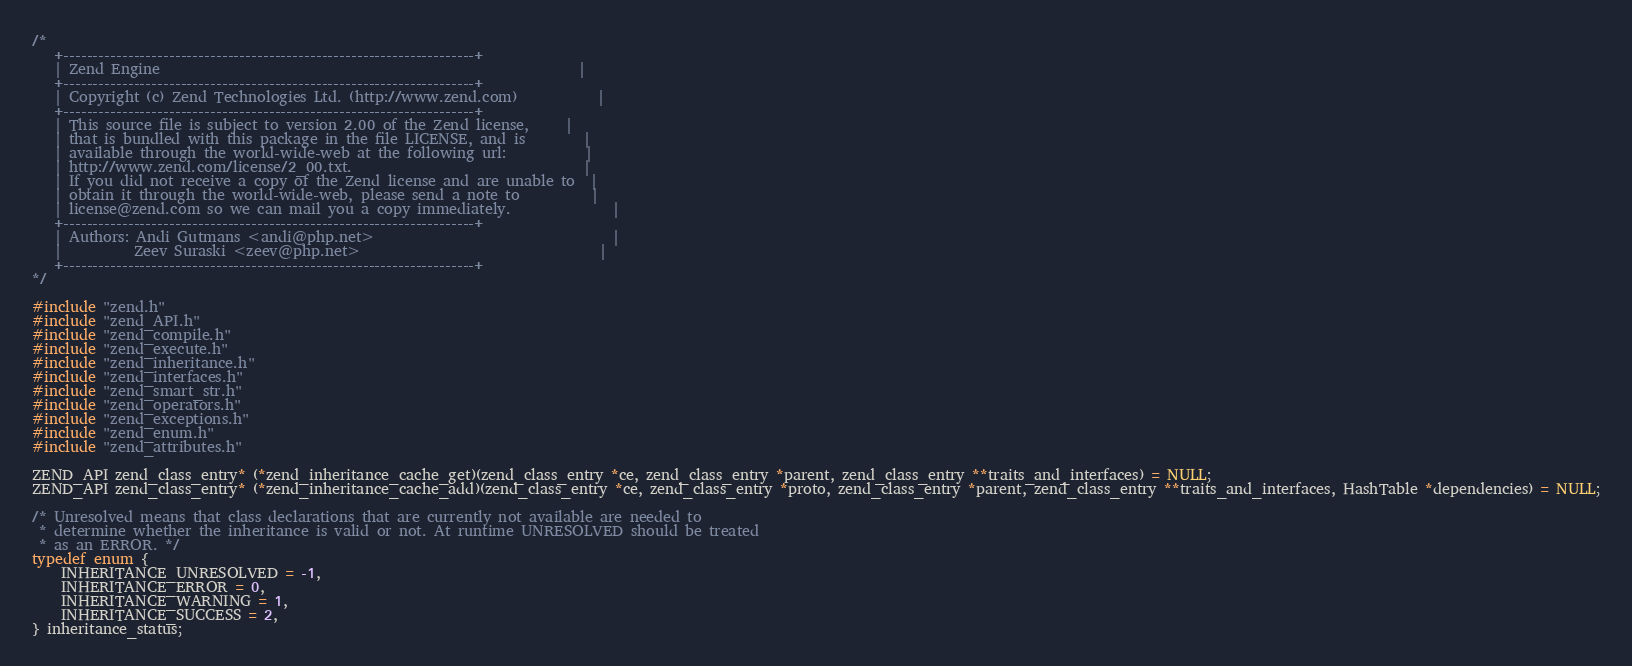Convert code to text. <code><loc_0><loc_0><loc_500><loc_500><_C_>/*
   +----------------------------------------------------------------------+
   | Zend Engine                                                          |
   +----------------------------------------------------------------------+
   | Copyright (c) Zend Technologies Ltd. (http://www.zend.com)           |
   +----------------------------------------------------------------------+
   | This source file is subject to version 2.00 of the Zend license,     |
   | that is bundled with this package in the file LICENSE, and is        |
   | available through the world-wide-web at the following url:           |
   | http://www.zend.com/license/2_00.txt.                                |
   | If you did not receive a copy of the Zend license and are unable to  |
   | obtain it through the world-wide-web, please send a note to          |
   | license@zend.com so we can mail you a copy immediately.              |
   +----------------------------------------------------------------------+
   | Authors: Andi Gutmans <andi@php.net>                                 |
   |          Zeev Suraski <zeev@php.net>                                 |
   +----------------------------------------------------------------------+
*/

#include "zend.h"
#include "zend_API.h"
#include "zend_compile.h"
#include "zend_execute.h"
#include "zend_inheritance.h"
#include "zend_interfaces.h"
#include "zend_smart_str.h"
#include "zend_operators.h"
#include "zend_exceptions.h"
#include "zend_enum.h"
#include "zend_attributes.h"

ZEND_API zend_class_entry* (*zend_inheritance_cache_get)(zend_class_entry *ce, zend_class_entry *parent, zend_class_entry **traits_and_interfaces) = NULL;
ZEND_API zend_class_entry* (*zend_inheritance_cache_add)(zend_class_entry *ce, zend_class_entry *proto, zend_class_entry *parent, zend_class_entry **traits_and_interfaces, HashTable *dependencies) = NULL;

/* Unresolved means that class declarations that are currently not available are needed to
 * determine whether the inheritance is valid or not. At runtime UNRESOLVED should be treated
 * as an ERROR. */
typedef enum {
	INHERITANCE_UNRESOLVED = -1,
	INHERITANCE_ERROR = 0,
	INHERITANCE_WARNING = 1,
	INHERITANCE_SUCCESS = 2,
} inheritance_status;
</code> 